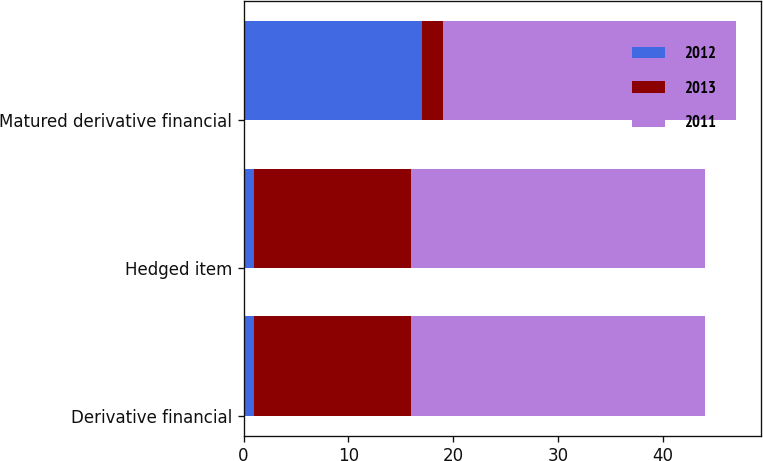Convert chart. <chart><loc_0><loc_0><loc_500><loc_500><stacked_bar_chart><ecel><fcel>Derivative financial<fcel>Hedged item<fcel>Matured derivative financial<nl><fcel>2012<fcel>1<fcel>1<fcel>17<nl><fcel>2013<fcel>15<fcel>15<fcel>2<nl><fcel>2011<fcel>28<fcel>28<fcel>28<nl></chart> 